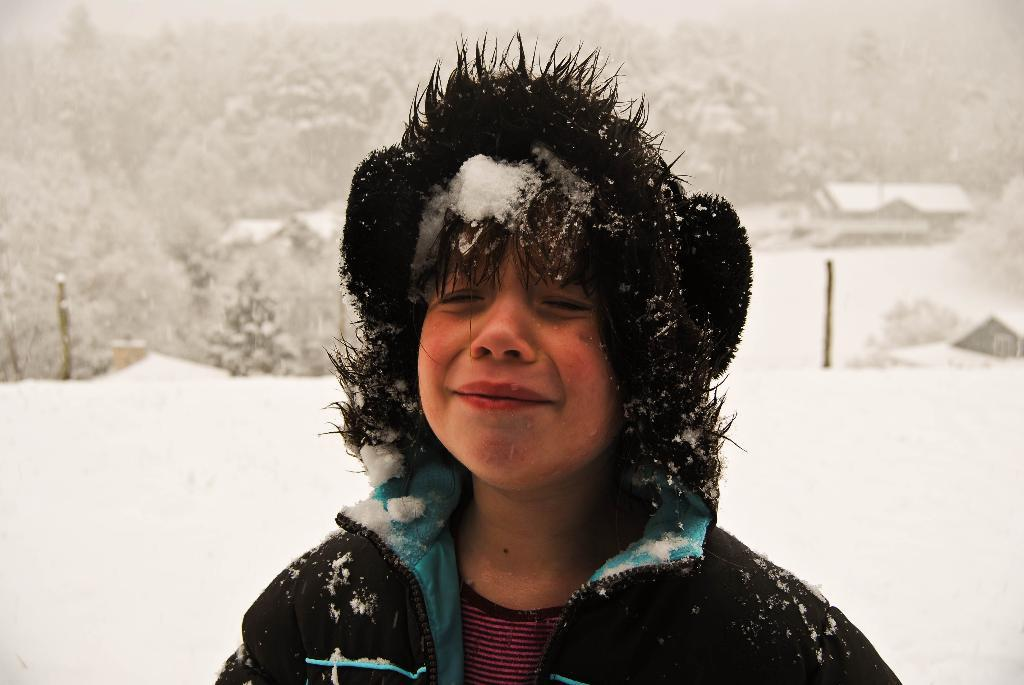What is the main subject of the image? The main subject of the image is a kid. What is the kid doing in the image? The kid is crying in the image. What can be seen in the background behind the kid? There are trees and wooden sticks in the background. What type of structures are visible in the distance? There are houses in the background. What type of punishment is the kid receiving from the doctor in the image? There is no doctor or punishment present in the image. Can you compare the size of the kid to the size of the houses in the background? It is not possible to accurately compare the size of the kid to the size of the houses in the image, as there is no reference point for scale. 